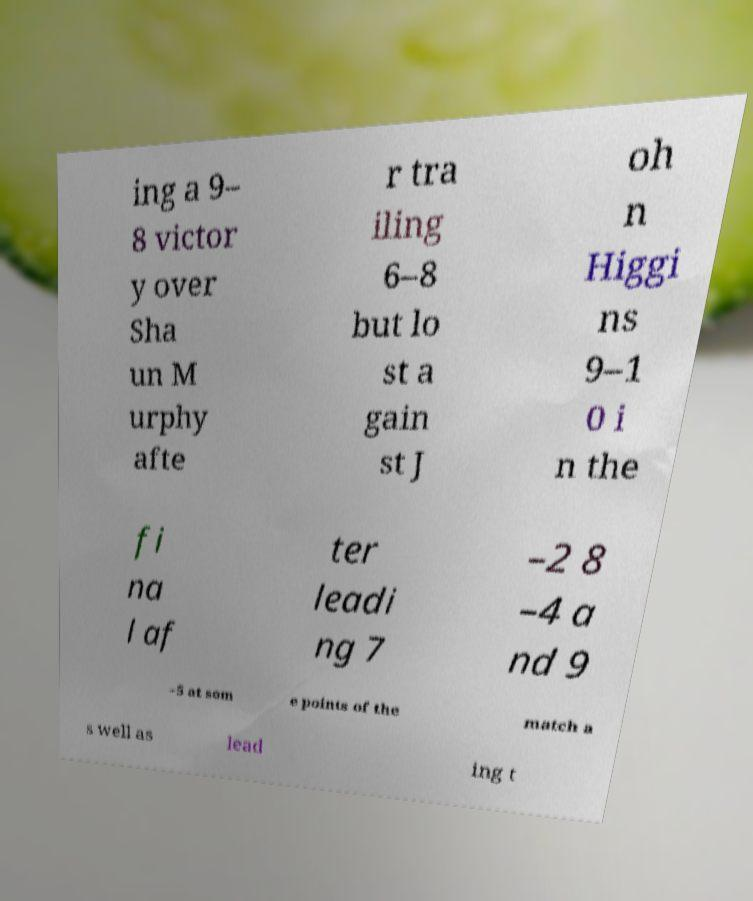What messages or text are displayed in this image? I need them in a readable, typed format. ing a 9– 8 victor y over Sha un M urphy afte r tra iling 6–8 but lo st a gain st J oh n Higgi ns 9–1 0 i n the fi na l af ter leadi ng 7 –2 8 –4 a nd 9 –5 at som e points of the match a s well as lead ing t 